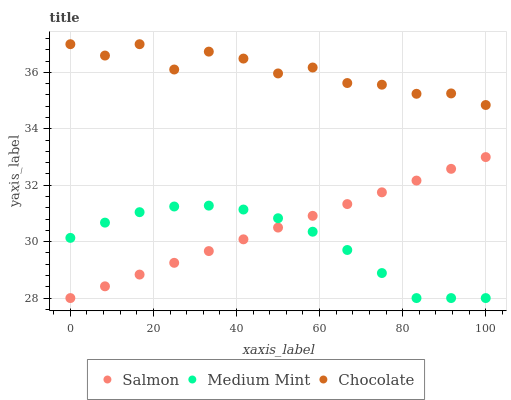Does Medium Mint have the minimum area under the curve?
Answer yes or no. Yes. Does Chocolate have the maximum area under the curve?
Answer yes or no. Yes. Does Salmon have the minimum area under the curve?
Answer yes or no. No. Does Salmon have the maximum area under the curve?
Answer yes or no. No. Is Salmon the smoothest?
Answer yes or no. Yes. Is Chocolate the roughest?
Answer yes or no. Yes. Is Chocolate the smoothest?
Answer yes or no. No. Is Salmon the roughest?
Answer yes or no. No. Does Medium Mint have the lowest value?
Answer yes or no. Yes. Does Chocolate have the lowest value?
Answer yes or no. No. Does Chocolate have the highest value?
Answer yes or no. Yes. Does Salmon have the highest value?
Answer yes or no. No. Is Salmon less than Chocolate?
Answer yes or no. Yes. Is Chocolate greater than Salmon?
Answer yes or no. Yes. Does Salmon intersect Medium Mint?
Answer yes or no. Yes. Is Salmon less than Medium Mint?
Answer yes or no. No. Is Salmon greater than Medium Mint?
Answer yes or no. No. Does Salmon intersect Chocolate?
Answer yes or no. No. 